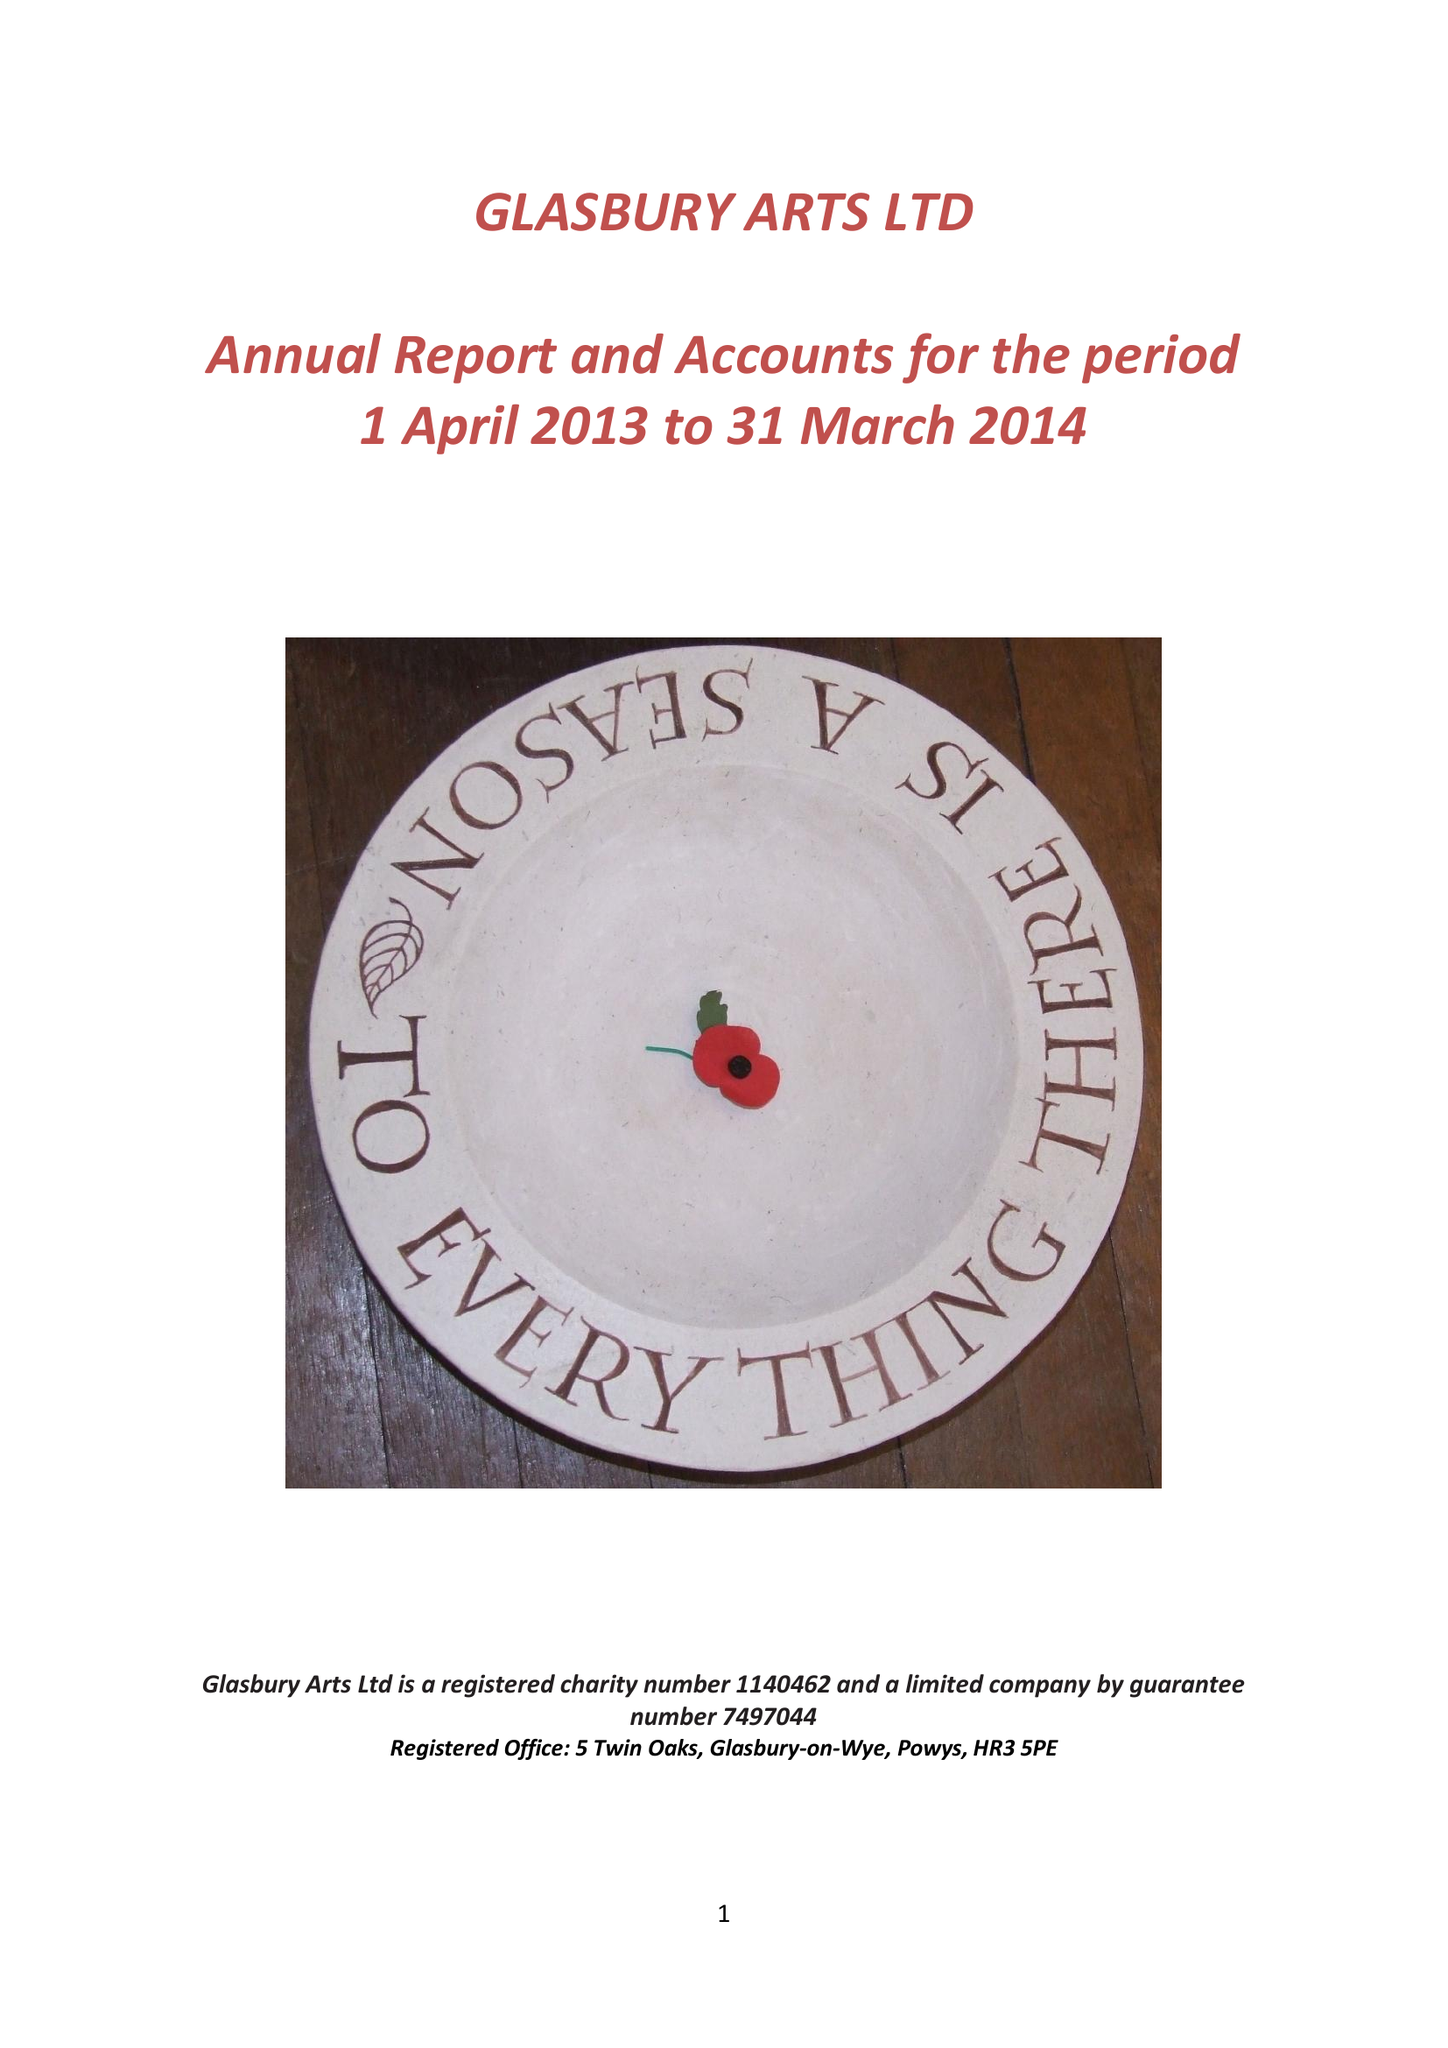What is the value for the income_annually_in_british_pounds?
Answer the question using a single word or phrase. 32583.00 